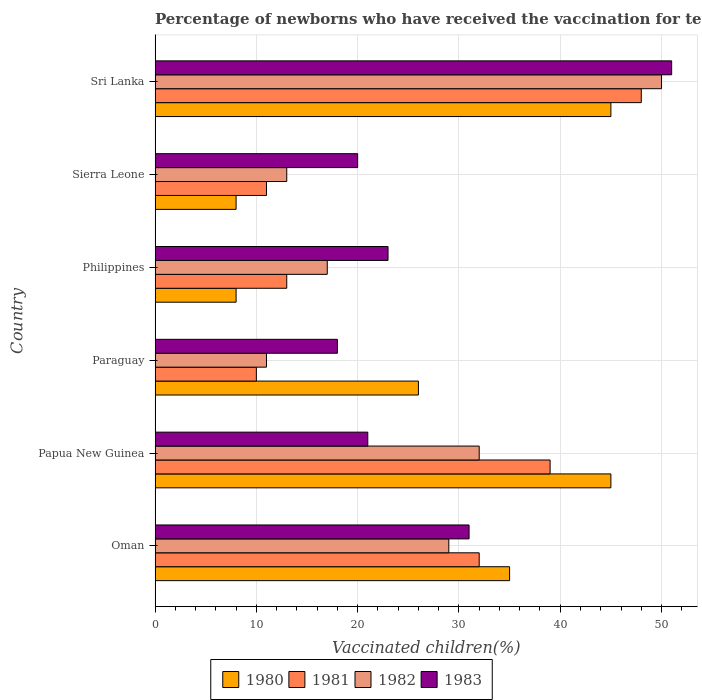How many different coloured bars are there?
Give a very brief answer. 4. How many groups of bars are there?
Offer a very short reply. 6. Are the number of bars per tick equal to the number of legend labels?
Your answer should be very brief. Yes. What is the label of the 1st group of bars from the top?
Your answer should be compact. Sri Lanka. In how many cases, is the number of bars for a given country not equal to the number of legend labels?
Ensure brevity in your answer.  0. What is the percentage of vaccinated children in 1982 in Oman?
Your answer should be compact. 29. Across all countries, what is the minimum percentage of vaccinated children in 1982?
Provide a short and direct response. 11. In which country was the percentage of vaccinated children in 1980 maximum?
Your answer should be compact. Papua New Guinea. In which country was the percentage of vaccinated children in 1982 minimum?
Provide a short and direct response. Paraguay. What is the total percentage of vaccinated children in 1983 in the graph?
Ensure brevity in your answer.  164. What is the difference between the percentage of vaccinated children in 1983 in Oman and that in Sierra Leone?
Provide a short and direct response. 11. What is the average percentage of vaccinated children in 1981 per country?
Give a very brief answer. 25.5. What is the difference between the percentage of vaccinated children in 1983 and percentage of vaccinated children in 1982 in Papua New Guinea?
Provide a short and direct response. -11. What is the ratio of the percentage of vaccinated children in 1981 in Oman to that in Papua New Guinea?
Make the answer very short. 0.82. Is the percentage of vaccinated children in 1983 in Sierra Leone less than that in Sri Lanka?
Your answer should be very brief. Yes. What is the difference between the highest and the second highest percentage of vaccinated children in 1981?
Your answer should be very brief. 9. Is the sum of the percentage of vaccinated children in 1982 in Oman and Philippines greater than the maximum percentage of vaccinated children in 1980 across all countries?
Your answer should be very brief. Yes. Is it the case that in every country, the sum of the percentage of vaccinated children in 1983 and percentage of vaccinated children in 1980 is greater than the percentage of vaccinated children in 1981?
Give a very brief answer. Yes. Are all the bars in the graph horizontal?
Your response must be concise. Yes. How many countries are there in the graph?
Offer a terse response. 6. Does the graph contain any zero values?
Make the answer very short. No. Where does the legend appear in the graph?
Offer a terse response. Bottom center. How many legend labels are there?
Offer a very short reply. 4. How are the legend labels stacked?
Your answer should be compact. Horizontal. What is the title of the graph?
Keep it short and to the point. Percentage of newborns who have received the vaccination for tetanus. Does "1971" appear as one of the legend labels in the graph?
Give a very brief answer. No. What is the label or title of the X-axis?
Provide a succinct answer. Vaccinated children(%). What is the label or title of the Y-axis?
Your answer should be very brief. Country. What is the Vaccinated children(%) of 1981 in Oman?
Your response must be concise. 32. What is the Vaccinated children(%) of 1982 in Oman?
Your response must be concise. 29. What is the Vaccinated children(%) of 1981 in Papua New Guinea?
Provide a succinct answer. 39. What is the Vaccinated children(%) of 1982 in Papua New Guinea?
Provide a short and direct response. 32. What is the Vaccinated children(%) in 1983 in Papua New Guinea?
Make the answer very short. 21. What is the Vaccinated children(%) in 1982 in Paraguay?
Your answer should be very brief. 11. What is the Vaccinated children(%) of 1980 in Philippines?
Keep it short and to the point. 8. What is the Vaccinated children(%) in 1983 in Philippines?
Provide a succinct answer. 23. What is the Vaccinated children(%) in 1980 in Sierra Leone?
Your answer should be very brief. 8. What is the Vaccinated children(%) of 1981 in Sierra Leone?
Your answer should be compact. 11. What is the Vaccinated children(%) in 1980 in Sri Lanka?
Offer a very short reply. 45. What is the Vaccinated children(%) of 1983 in Sri Lanka?
Ensure brevity in your answer.  51. Across all countries, what is the maximum Vaccinated children(%) in 1980?
Give a very brief answer. 45. Across all countries, what is the maximum Vaccinated children(%) in 1981?
Ensure brevity in your answer.  48. Across all countries, what is the maximum Vaccinated children(%) of 1982?
Your answer should be very brief. 50. Across all countries, what is the minimum Vaccinated children(%) of 1982?
Ensure brevity in your answer.  11. Across all countries, what is the minimum Vaccinated children(%) in 1983?
Your answer should be very brief. 18. What is the total Vaccinated children(%) of 1980 in the graph?
Your answer should be compact. 167. What is the total Vaccinated children(%) of 1981 in the graph?
Ensure brevity in your answer.  153. What is the total Vaccinated children(%) of 1982 in the graph?
Offer a very short reply. 152. What is the total Vaccinated children(%) in 1983 in the graph?
Give a very brief answer. 164. What is the difference between the Vaccinated children(%) in 1980 in Oman and that in Papua New Guinea?
Make the answer very short. -10. What is the difference between the Vaccinated children(%) of 1983 in Oman and that in Papua New Guinea?
Provide a succinct answer. 10. What is the difference between the Vaccinated children(%) in 1983 in Oman and that in Paraguay?
Ensure brevity in your answer.  13. What is the difference between the Vaccinated children(%) of 1980 in Oman and that in Philippines?
Make the answer very short. 27. What is the difference between the Vaccinated children(%) in 1981 in Oman and that in Philippines?
Provide a short and direct response. 19. What is the difference between the Vaccinated children(%) in 1982 in Oman and that in Sierra Leone?
Your response must be concise. 16. What is the difference between the Vaccinated children(%) of 1983 in Oman and that in Sierra Leone?
Ensure brevity in your answer.  11. What is the difference between the Vaccinated children(%) in 1980 in Oman and that in Sri Lanka?
Your answer should be compact. -10. What is the difference between the Vaccinated children(%) in 1981 in Oman and that in Sri Lanka?
Offer a very short reply. -16. What is the difference between the Vaccinated children(%) in 1982 in Oman and that in Sri Lanka?
Your response must be concise. -21. What is the difference between the Vaccinated children(%) in 1981 in Papua New Guinea and that in Philippines?
Your answer should be very brief. 26. What is the difference between the Vaccinated children(%) in 1982 in Papua New Guinea and that in Philippines?
Your response must be concise. 15. What is the difference between the Vaccinated children(%) of 1980 in Papua New Guinea and that in Sierra Leone?
Provide a succinct answer. 37. What is the difference between the Vaccinated children(%) in 1981 in Papua New Guinea and that in Sierra Leone?
Offer a terse response. 28. What is the difference between the Vaccinated children(%) of 1982 in Papua New Guinea and that in Sierra Leone?
Offer a very short reply. 19. What is the difference between the Vaccinated children(%) in 1983 in Papua New Guinea and that in Sierra Leone?
Your answer should be compact. 1. What is the difference between the Vaccinated children(%) in 1983 in Papua New Guinea and that in Sri Lanka?
Make the answer very short. -30. What is the difference between the Vaccinated children(%) in 1980 in Paraguay and that in Philippines?
Keep it short and to the point. 18. What is the difference between the Vaccinated children(%) of 1982 in Paraguay and that in Philippines?
Offer a very short reply. -6. What is the difference between the Vaccinated children(%) of 1980 in Paraguay and that in Sierra Leone?
Your response must be concise. 18. What is the difference between the Vaccinated children(%) of 1981 in Paraguay and that in Sierra Leone?
Provide a short and direct response. -1. What is the difference between the Vaccinated children(%) of 1983 in Paraguay and that in Sierra Leone?
Your response must be concise. -2. What is the difference between the Vaccinated children(%) of 1981 in Paraguay and that in Sri Lanka?
Keep it short and to the point. -38. What is the difference between the Vaccinated children(%) of 1982 in Paraguay and that in Sri Lanka?
Ensure brevity in your answer.  -39. What is the difference between the Vaccinated children(%) in 1983 in Paraguay and that in Sri Lanka?
Give a very brief answer. -33. What is the difference between the Vaccinated children(%) of 1981 in Philippines and that in Sierra Leone?
Your answer should be very brief. 2. What is the difference between the Vaccinated children(%) of 1982 in Philippines and that in Sierra Leone?
Ensure brevity in your answer.  4. What is the difference between the Vaccinated children(%) in 1983 in Philippines and that in Sierra Leone?
Provide a succinct answer. 3. What is the difference between the Vaccinated children(%) in 1980 in Philippines and that in Sri Lanka?
Offer a terse response. -37. What is the difference between the Vaccinated children(%) of 1981 in Philippines and that in Sri Lanka?
Give a very brief answer. -35. What is the difference between the Vaccinated children(%) of 1982 in Philippines and that in Sri Lanka?
Offer a terse response. -33. What is the difference between the Vaccinated children(%) of 1980 in Sierra Leone and that in Sri Lanka?
Your answer should be very brief. -37. What is the difference between the Vaccinated children(%) in 1981 in Sierra Leone and that in Sri Lanka?
Keep it short and to the point. -37. What is the difference between the Vaccinated children(%) in 1982 in Sierra Leone and that in Sri Lanka?
Your answer should be very brief. -37. What is the difference between the Vaccinated children(%) of 1983 in Sierra Leone and that in Sri Lanka?
Provide a succinct answer. -31. What is the difference between the Vaccinated children(%) in 1980 in Oman and the Vaccinated children(%) in 1981 in Papua New Guinea?
Your response must be concise. -4. What is the difference between the Vaccinated children(%) of 1980 in Oman and the Vaccinated children(%) of 1983 in Papua New Guinea?
Ensure brevity in your answer.  14. What is the difference between the Vaccinated children(%) of 1981 in Oman and the Vaccinated children(%) of 1982 in Papua New Guinea?
Give a very brief answer. 0. What is the difference between the Vaccinated children(%) in 1980 in Oman and the Vaccinated children(%) in 1982 in Paraguay?
Give a very brief answer. 24. What is the difference between the Vaccinated children(%) of 1981 in Oman and the Vaccinated children(%) of 1982 in Paraguay?
Make the answer very short. 21. What is the difference between the Vaccinated children(%) in 1982 in Oman and the Vaccinated children(%) in 1983 in Paraguay?
Offer a very short reply. 11. What is the difference between the Vaccinated children(%) in 1980 in Oman and the Vaccinated children(%) in 1983 in Philippines?
Your response must be concise. 12. What is the difference between the Vaccinated children(%) in 1981 in Oman and the Vaccinated children(%) in 1982 in Philippines?
Your answer should be compact. 15. What is the difference between the Vaccinated children(%) of 1982 in Oman and the Vaccinated children(%) of 1983 in Philippines?
Offer a very short reply. 6. What is the difference between the Vaccinated children(%) of 1980 in Oman and the Vaccinated children(%) of 1981 in Sierra Leone?
Offer a very short reply. 24. What is the difference between the Vaccinated children(%) in 1980 in Oman and the Vaccinated children(%) in 1982 in Sierra Leone?
Ensure brevity in your answer.  22. What is the difference between the Vaccinated children(%) of 1981 in Oman and the Vaccinated children(%) of 1983 in Sierra Leone?
Your answer should be very brief. 12. What is the difference between the Vaccinated children(%) of 1980 in Oman and the Vaccinated children(%) of 1981 in Sri Lanka?
Offer a terse response. -13. What is the difference between the Vaccinated children(%) of 1980 in Oman and the Vaccinated children(%) of 1983 in Sri Lanka?
Your response must be concise. -16. What is the difference between the Vaccinated children(%) of 1981 in Oman and the Vaccinated children(%) of 1982 in Sri Lanka?
Your answer should be very brief. -18. What is the difference between the Vaccinated children(%) in 1980 in Papua New Guinea and the Vaccinated children(%) in 1981 in Paraguay?
Make the answer very short. 35. What is the difference between the Vaccinated children(%) in 1980 in Papua New Guinea and the Vaccinated children(%) in 1982 in Paraguay?
Offer a very short reply. 34. What is the difference between the Vaccinated children(%) of 1980 in Papua New Guinea and the Vaccinated children(%) of 1983 in Paraguay?
Your answer should be very brief. 27. What is the difference between the Vaccinated children(%) in 1982 in Papua New Guinea and the Vaccinated children(%) in 1983 in Paraguay?
Ensure brevity in your answer.  14. What is the difference between the Vaccinated children(%) in 1981 in Papua New Guinea and the Vaccinated children(%) in 1982 in Philippines?
Your response must be concise. 22. What is the difference between the Vaccinated children(%) of 1982 in Papua New Guinea and the Vaccinated children(%) of 1983 in Philippines?
Provide a short and direct response. 9. What is the difference between the Vaccinated children(%) in 1980 in Papua New Guinea and the Vaccinated children(%) in 1983 in Sierra Leone?
Your response must be concise. 25. What is the difference between the Vaccinated children(%) in 1981 in Papua New Guinea and the Vaccinated children(%) in 1982 in Sierra Leone?
Your answer should be very brief. 26. What is the difference between the Vaccinated children(%) in 1982 in Papua New Guinea and the Vaccinated children(%) in 1983 in Sierra Leone?
Give a very brief answer. 12. What is the difference between the Vaccinated children(%) in 1980 in Papua New Guinea and the Vaccinated children(%) in 1981 in Sri Lanka?
Your answer should be very brief. -3. What is the difference between the Vaccinated children(%) of 1980 in Papua New Guinea and the Vaccinated children(%) of 1983 in Sri Lanka?
Ensure brevity in your answer.  -6. What is the difference between the Vaccinated children(%) of 1981 in Papua New Guinea and the Vaccinated children(%) of 1982 in Sri Lanka?
Provide a succinct answer. -11. What is the difference between the Vaccinated children(%) of 1982 in Papua New Guinea and the Vaccinated children(%) of 1983 in Sri Lanka?
Offer a very short reply. -19. What is the difference between the Vaccinated children(%) in 1980 in Paraguay and the Vaccinated children(%) in 1983 in Philippines?
Provide a succinct answer. 3. What is the difference between the Vaccinated children(%) of 1980 in Paraguay and the Vaccinated children(%) of 1981 in Sierra Leone?
Ensure brevity in your answer.  15. What is the difference between the Vaccinated children(%) in 1980 in Paraguay and the Vaccinated children(%) in 1982 in Sierra Leone?
Provide a succinct answer. 13. What is the difference between the Vaccinated children(%) of 1981 in Paraguay and the Vaccinated children(%) of 1982 in Sierra Leone?
Ensure brevity in your answer.  -3. What is the difference between the Vaccinated children(%) of 1982 in Paraguay and the Vaccinated children(%) of 1983 in Sierra Leone?
Your response must be concise. -9. What is the difference between the Vaccinated children(%) of 1980 in Paraguay and the Vaccinated children(%) of 1981 in Sri Lanka?
Your response must be concise. -22. What is the difference between the Vaccinated children(%) of 1980 in Paraguay and the Vaccinated children(%) of 1983 in Sri Lanka?
Keep it short and to the point. -25. What is the difference between the Vaccinated children(%) of 1981 in Paraguay and the Vaccinated children(%) of 1983 in Sri Lanka?
Offer a very short reply. -41. What is the difference between the Vaccinated children(%) in 1980 in Philippines and the Vaccinated children(%) in 1981 in Sierra Leone?
Your answer should be compact. -3. What is the difference between the Vaccinated children(%) in 1981 in Philippines and the Vaccinated children(%) in 1983 in Sierra Leone?
Offer a terse response. -7. What is the difference between the Vaccinated children(%) in 1980 in Philippines and the Vaccinated children(%) in 1981 in Sri Lanka?
Offer a terse response. -40. What is the difference between the Vaccinated children(%) in 1980 in Philippines and the Vaccinated children(%) in 1982 in Sri Lanka?
Your answer should be very brief. -42. What is the difference between the Vaccinated children(%) in 1980 in Philippines and the Vaccinated children(%) in 1983 in Sri Lanka?
Provide a succinct answer. -43. What is the difference between the Vaccinated children(%) in 1981 in Philippines and the Vaccinated children(%) in 1982 in Sri Lanka?
Offer a very short reply. -37. What is the difference between the Vaccinated children(%) of 1981 in Philippines and the Vaccinated children(%) of 1983 in Sri Lanka?
Your response must be concise. -38. What is the difference between the Vaccinated children(%) in 1982 in Philippines and the Vaccinated children(%) in 1983 in Sri Lanka?
Your response must be concise. -34. What is the difference between the Vaccinated children(%) in 1980 in Sierra Leone and the Vaccinated children(%) in 1981 in Sri Lanka?
Ensure brevity in your answer.  -40. What is the difference between the Vaccinated children(%) in 1980 in Sierra Leone and the Vaccinated children(%) in 1982 in Sri Lanka?
Make the answer very short. -42. What is the difference between the Vaccinated children(%) in 1980 in Sierra Leone and the Vaccinated children(%) in 1983 in Sri Lanka?
Offer a terse response. -43. What is the difference between the Vaccinated children(%) of 1981 in Sierra Leone and the Vaccinated children(%) of 1982 in Sri Lanka?
Your response must be concise. -39. What is the difference between the Vaccinated children(%) in 1982 in Sierra Leone and the Vaccinated children(%) in 1983 in Sri Lanka?
Offer a very short reply. -38. What is the average Vaccinated children(%) in 1980 per country?
Provide a succinct answer. 27.83. What is the average Vaccinated children(%) in 1981 per country?
Provide a succinct answer. 25.5. What is the average Vaccinated children(%) in 1982 per country?
Provide a short and direct response. 25.33. What is the average Vaccinated children(%) of 1983 per country?
Your answer should be very brief. 27.33. What is the difference between the Vaccinated children(%) in 1980 and Vaccinated children(%) in 1981 in Oman?
Ensure brevity in your answer.  3. What is the difference between the Vaccinated children(%) of 1980 and Vaccinated children(%) of 1982 in Oman?
Keep it short and to the point. 6. What is the difference between the Vaccinated children(%) in 1980 and Vaccinated children(%) in 1983 in Oman?
Provide a succinct answer. 4. What is the difference between the Vaccinated children(%) in 1981 and Vaccinated children(%) in 1983 in Oman?
Your answer should be compact. 1. What is the difference between the Vaccinated children(%) in 1982 and Vaccinated children(%) in 1983 in Oman?
Your answer should be very brief. -2. What is the difference between the Vaccinated children(%) in 1981 and Vaccinated children(%) in 1983 in Papua New Guinea?
Offer a terse response. 18. What is the difference between the Vaccinated children(%) of 1982 and Vaccinated children(%) of 1983 in Papua New Guinea?
Provide a succinct answer. 11. What is the difference between the Vaccinated children(%) in 1980 and Vaccinated children(%) in 1983 in Paraguay?
Ensure brevity in your answer.  8. What is the difference between the Vaccinated children(%) in 1981 and Vaccinated children(%) in 1982 in Paraguay?
Your response must be concise. -1. What is the difference between the Vaccinated children(%) in 1981 and Vaccinated children(%) in 1983 in Paraguay?
Your answer should be compact. -8. What is the difference between the Vaccinated children(%) in 1982 and Vaccinated children(%) in 1983 in Paraguay?
Provide a succinct answer. -7. What is the difference between the Vaccinated children(%) of 1980 and Vaccinated children(%) of 1981 in Philippines?
Your answer should be compact. -5. What is the difference between the Vaccinated children(%) of 1980 and Vaccinated children(%) of 1983 in Philippines?
Your answer should be compact. -15. What is the difference between the Vaccinated children(%) in 1981 and Vaccinated children(%) in 1982 in Philippines?
Provide a succinct answer. -4. What is the difference between the Vaccinated children(%) of 1981 and Vaccinated children(%) of 1983 in Philippines?
Offer a very short reply. -10. What is the difference between the Vaccinated children(%) of 1982 and Vaccinated children(%) of 1983 in Philippines?
Your answer should be very brief. -6. What is the difference between the Vaccinated children(%) in 1980 and Vaccinated children(%) in 1981 in Sierra Leone?
Offer a very short reply. -3. What is the difference between the Vaccinated children(%) of 1980 and Vaccinated children(%) of 1982 in Sierra Leone?
Ensure brevity in your answer.  -5. What is the difference between the Vaccinated children(%) of 1980 and Vaccinated children(%) of 1983 in Sierra Leone?
Give a very brief answer. -12. What is the difference between the Vaccinated children(%) in 1981 and Vaccinated children(%) in 1982 in Sierra Leone?
Offer a very short reply. -2. What is the difference between the Vaccinated children(%) of 1981 and Vaccinated children(%) of 1983 in Sierra Leone?
Your response must be concise. -9. What is the difference between the Vaccinated children(%) in 1982 and Vaccinated children(%) in 1983 in Sierra Leone?
Make the answer very short. -7. What is the difference between the Vaccinated children(%) in 1980 and Vaccinated children(%) in 1982 in Sri Lanka?
Your answer should be compact. -5. What is the difference between the Vaccinated children(%) of 1982 and Vaccinated children(%) of 1983 in Sri Lanka?
Make the answer very short. -1. What is the ratio of the Vaccinated children(%) of 1980 in Oman to that in Papua New Guinea?
Give a very brief answer. 0.78. What is the ratio of the Vaccinated children(%) of 1981 in Oman to that in Papua New Guinea?
Your answer should be compact. 0.82. What is the ratio of the Vaccinated children(%) of 1982 in Oman to that in Papua New Guinea?
Offer a terse response. 0.91. What is the ratio of the Vaccinated children(%) in 1983 in Oman to that in Papua New Guinea?
Your answer should be compact. 1.48. What is the ratio of the Vaccinated children(%) in 1980 in Oman to that in Paraguay?
Give a very brief answer. 1.35. What is the ratio of the Vaccinated children(%) of 1982 in Oman to that in Paraguay?
Ensure brevity in your answer.  2.64. What is the ratio of the Vaccinated children(%) of 1983 in Oman to that in Paraguay?
Make the answer very short. 1.72. What is the ratio of the Vaccinated children(%) in 1980 in Oman to that in Philippines?
Provide a succinct answer. 4.38. What is the ratio of the Vaccinated children(%) of 1981 in Oman to that in Philippines?
Provide a succinct answer. 2.46. What is the ratio of the Vaccinated children(%) of 1982 in Oman to that in Philippines?
Keep it short and to the point. 1.71. What is the ratio of the Vaccinated children(%) of 1983 in Oman to that in Philippines?
Offer a terse response. 1.35. What is the ratio of the Vaccinated children(%) of 1980 in Oman to that in Sierra Leone?
Your answer should be compact. 4.38. What is the ratio of the Vaccinated children(%) in 1981 in Oman to that in Sierra Leone?
Offer a very short reply. 2.91. What is the ratio of the Vaccinated children(%) in 1982 in Oman to that in Sierra Leone?
Your answer should be very brief. 2.23. What is the ratio of the Vaccinated children(%) of 1983 in Oman to that in Sierra Leone?
Provide a short and direct response. 1.55. What is the ratio of the Vaccinated children(%) in 1981 in Oman to that in Sri Lanka?
Your response must be concise. 0.67. What is the ratio of the Vaccinated children(%) in 1982 in Oman to that in Sri Lanka?
Make the answer very short. 0.58. What is the ratio of the Vaccinated children(%) in 1983 in Oman to that in Sri Lanka?
Make the answer very short. 0.61. What is the ratio of the Vaccinated children(%) of 1980 in Papua New Guinea to that in Paraguay?
Provide a succinct answer. 1.73. What is the ratio of the Vaccinated children(%) in 1982 in Papua New Guinea to that in Paraguay?
Ensure brevity in your answer.  2.91. What is the ratio of the Vaccinated children(%) in 1980 in Papua New Guinea to that in Philippines?
Provide a succinct answer. 5.62. What is the ratio of the Vaccinated children(%) in 1981 in Papua New Guinea to that in Philippines?
Your response must be concise. 3. What is the ratio of the Vaccinated children(%) in 1982 in Papua New Guinea to that in Philippines?
Provide a succinct answer. 1.88. What is the ratio of the Vaccinated children(%) of 1980 in Papua New Guinea to that in Sierra Leone?
Keep it short and to the point. 5.62. What is the ratio of the Vaccinated children(%) of 1981 in Papua New Guinea to that in Sierra Leone?
Provide a short and direct response. 3.55. What is the ratio of the Vaccinated children(%) of 1982 in Papua New Guinea to that in Sierra Leone?
Your answer should be very brief. 2.46. What is the ratio of the Vaccinated children(%) in 1981 in Papua New Guinea to that in Sri Lanka?
Your response must be concise. 0.81. What is the ratio of the Vaccinated children(%) of 1982 in Papua New Guinea to that in Sri Lanka?
Provide a short and direct response. 0.64. What is the ratio of the Vaccinated children(%) in 1983 in Papua New Guinea to that in Sri Lanka?
Your response must be concise. 0.41. What is the ratio of the Vaccinated children(%) in 1980 in Paraguay to that in Philippines?
Your answer should be compact. 3.25. What is the ratio of the Vaccinated children(%) in 1981 in Paraguay to that in Philippines?
Your answer should be very brief. 0.77. What is the ratio of the Vaccinated children(%) in 1982 in Paraguay to that in Philippines?
Give a very brief answer. 0.65. What is the ratio of the Vaccinated children(%) of 1983 in Paraguay to that in Philippines?
Provide a short and direct response. 0.78. What is the ratio of the Vaccinated children(%) of 1981 in Paraguay to that in Sierra Leone?
Give a very brief answer. 0.91. What is the ratio of the Vaccinated children(%) of 1982 in Paraguay to that in Sierra Leone?
Ensure brevity in your answer.  0.85. What is the ratio of the Vaccinated children(%) of 1980 in Paraguay to that in Sri Lanka?
Offer a very short reply. 0.58. What is the ratio of the Vaccinated children(%) of 1981 in Paraguay to that in Sri Lanka?
Your answer should be compact. 0.21. What is the ratio of the Vaccinated children(%) of 1982 in Paraguay to that in Sri Lanka?
Your answer should be very brief. 0.22. What is the ratio of the Vaccinated children(%) of 1983 in Paraguay to that in Sri Lanka?
Provide a short and direct response. 0.35. What is the ratio of the Vaccinated children(%) in 1980 in Philippines to that in Sierra Leone?
Ensure brevity in your answer.  1. What is the ratio of the Vaccinated children(%) in 1981 in Philippines to that in Sierra Leone?
Keep it short and to the point. 1.18. What is the ratio of the Vaccinated children(%) of 1982 in Philippines to that in Sierra Leone?
Offer a terse response. 1.31. What is the ratio of the Vaccinated children(%) in 1983 in Philippines to that in Sierra Leone?
Your response must be concise. 1.15. What is the ratio of the Vaccinated children(%) in 1980 in Philippines to that in Sri Lanka?
Provide a succinct answer. 0.18. What is the ratio of the Vaccinated children(%) in 1981 in Philippines to that in Sri Lanka?
Keep it short and to the point. 0.27. What is the ratio of the Vaccinated children(%) of 1982 in Philippines to that in Sri Lanka?
Provide a short and direct response. 0.34. What is the ratio of the Vaccinated children(%) of 1983 in Philippines to that in Sri Lanka?
Offer a terse response. 0.45. What is the ratio of the Vaccinated children(%) in 1980 in Sierra Leone to that in Sri Lanka?
Provide a short and direct response. 0.18. What is the ratio of the Vaccinated children(%) in 1981 in Sierra Leone to that in Sri Lanka?
Your response must be concise. 0.23. What is the ratio of the Vaccinated children(%) in 1982 in Sierra Leone to that in Sri Lanka?
Your answer should be very brief. 0.26. What is the ratio of the Vaccinated children(%) in 1983 in Sierra Leone to that in Sri Lanka?
Provide a short and direct response. 0.39. What is the difference between the highest and the second highest Vaccinated children(%) in 1981?
Your answer should be very brief. 9. What is the difference between the highest and the second highest Vaccinated children(%) in 1983?
Ensure brevity in your answer.  20. What is the difference between the highest and the lowest Vaccinated children(%) of 1980?
Make the answer very short. 37. What is the difference between the highest and the lowest Vaccinated children(%) of 1981?
Offer a terse response. 38. 